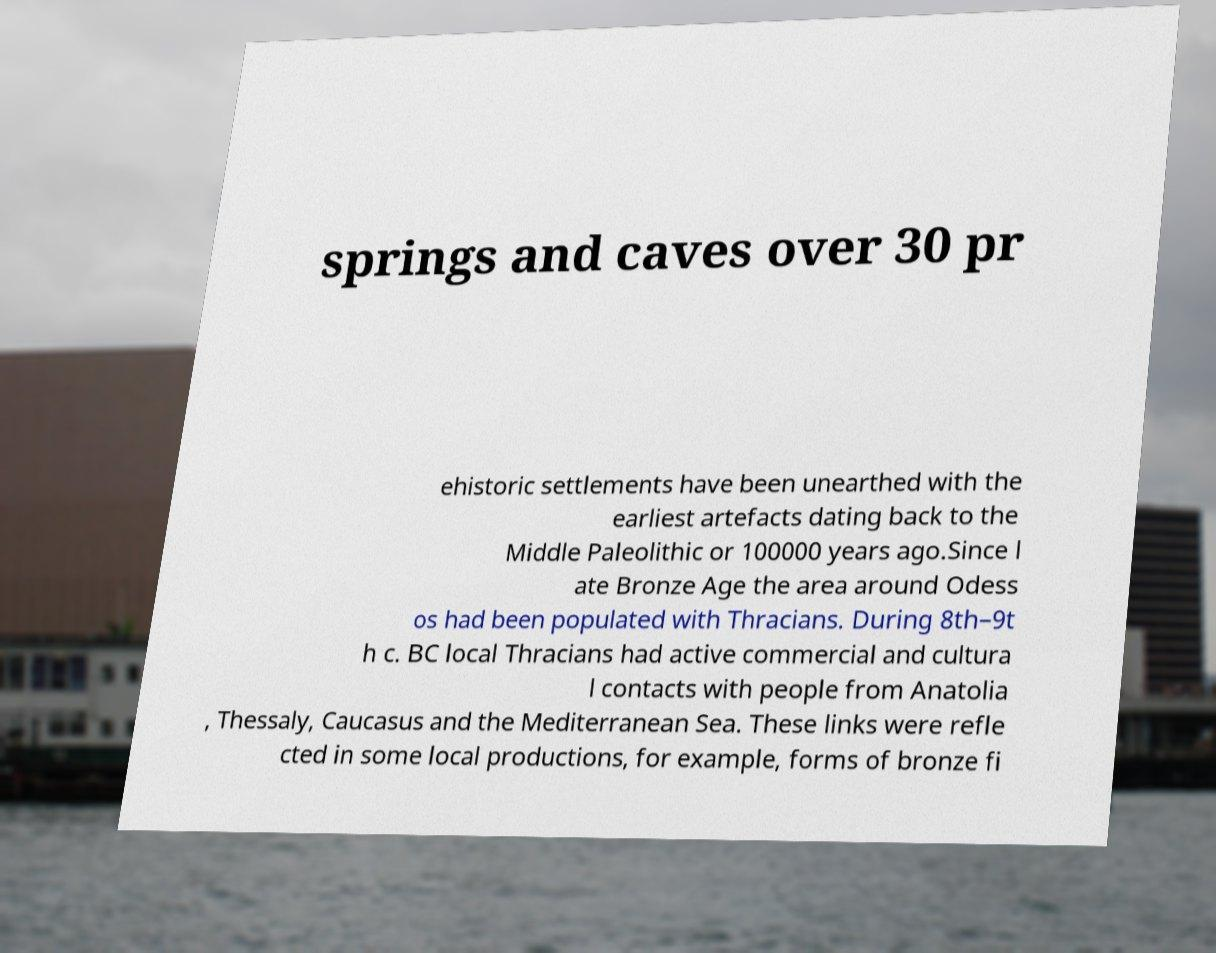Could you extract and type out the text from this image? springs and caves over 30 pr ehistoric settlements have been unearthed with the earliest artefacts dating back to the Middle Paleolithic or 100000 years ago.Since l ate Bronze Age the area around Odess os had been populated with Thracians. During 8th–9t h c. BC local Thracians had active commercial and cultura l contacts with people from Anatolia , Thessaly, Caucasus and the Mediterranean Sea. These links were refle cted in some local productions, for example, forms of bronze fi 